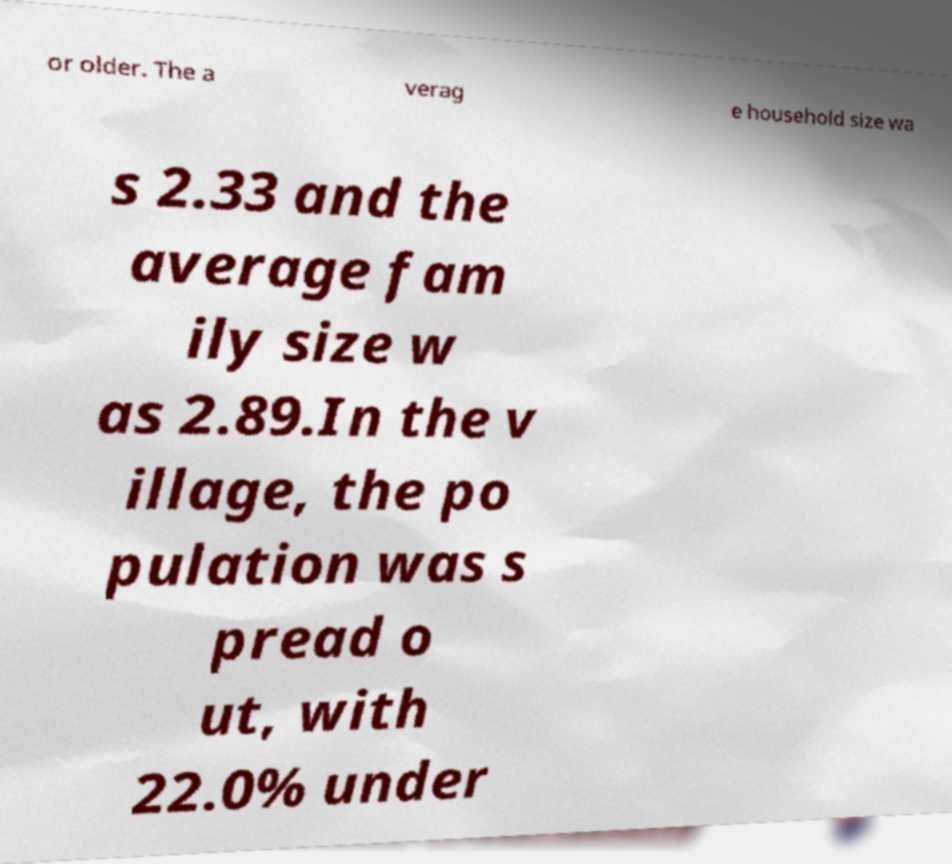I need the written content from this picture converted into text. Can you do that? or older. The a verag e household size wa s 2.33 and the average fam ily size w as 2.89.In the v illage, the po pulation was s pread o ut, with 22.0% under 